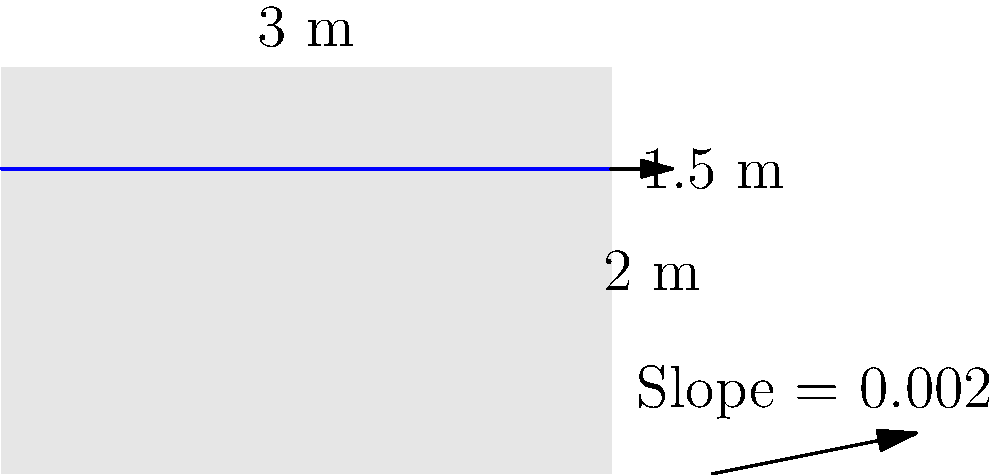As a curriculum developer, you're designing a civil engineering course module on hydraulics. Calculate the flow rate in an open rectangular channel with the following specifications:
- Width: 3 meters
- Water depth: 1.5 meters
- Channel slope: 0.002
- Manning's roughness coefficient: 0.013 (concrete-lined channel)

Round your answer to the nearest whole number in cubic meters per second (m³/s). To calculate the flow rate in an open channel, we'll use Manning's equation:

$$ Q = \frac{1}{n} A R^{\frac{2}{3}} S^{\frac{1}{2}} $$

Where:
$Q$ = flow rate (m³/s)
$n$ = Manning's roughness coefficient
$A$ = cross-sectional area of flow (m²)
$R$ = hydraulic radius (m)
$S$ = channel slope

Step 1: Calculate the cross-sectional area (A)
$A = \text{width} \times \text{depth} = 3 \text{ m} \times 1.5 \text{ m} = 4.5 \text{ m}^2$

Step 2: Calculate the wetted perimeter (P)
$P = \text{width} + 2 \times \text{depth} = 3 \text{ m} + 2 \times 1.5 \text{ m} = 6 \text{ m}$

Step 3: Calculate the hydraulic radius (R)
$R = \frac{A}{P} = \frac{4.5 \text{ m}^2}{6 \text{ m}} = 0.75 \text{ m}$

Step 4: Apply Manning's equation
$Q = \frac{1}{0.013} \times 4.5 \times 0.75^{\frac{2}{3}} \times 0.002^{\frac{1}{2}}$

Step 5: Calculate and round to the nearest whole number
$Q = 11.56 \text{ m}^3/\text{s} \approx 12 \text{ m}^3/\text{s}$
Answer: 12 m³/s 